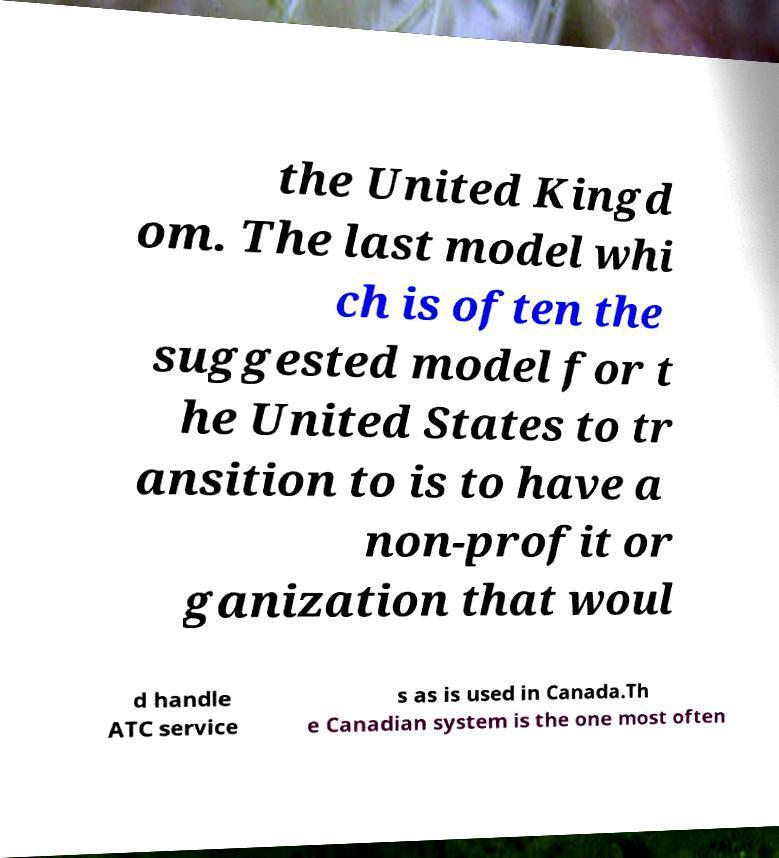Could you extract and type out the text from this image? the United Kingd om. The last model whi ch is often the suggested model for t he United States to tr ansition to is to have a non-profit or ganization that woul d handle ATC service s as is used in Canada.Th e Canadian system is the one most often 